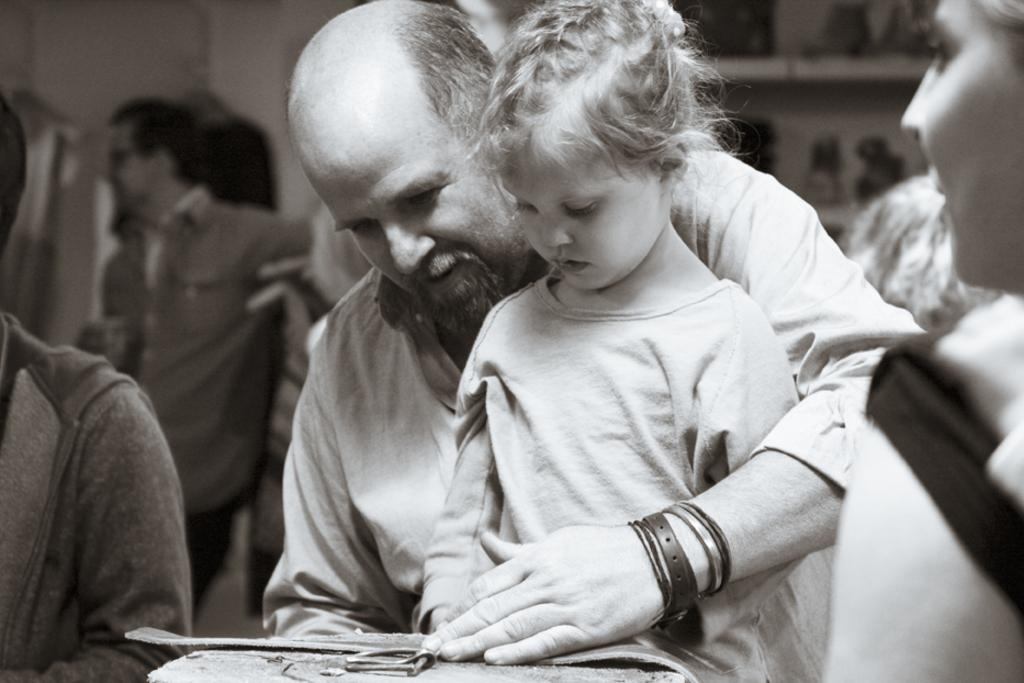What is the man in the image holding? The man is holding an object in the image. Can you describe the scene in the background of the image? There is a group of people in the background of the image. What can be seen on the shelf in the image? There are objects on a shelf in the image. What is the plot of the story being told by the tank in the image? There is no tank present in the image, and therefore no story being told by a tank. 